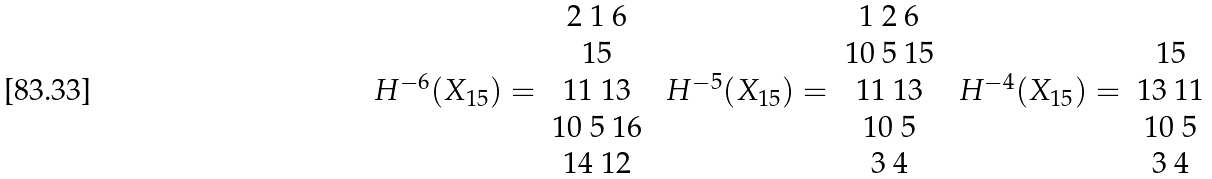<formula> <loc_0><loc_0><loc_500><loc_500>\begin{array} { c c } & 2 \ 1 \ 6 \\ & 1 5 \\ H ^ { - 6 } ( X _ { 1 5 } ) = & 1 1 \ 1 3 \\ & 1 0 \ 5 \ 1 6 \\ & 1 4 \ 1 2 \\ \end{array} \ \begin{array} { c c } & 1 \ 2 \ 6 \\ & 1 0 \ 5 \ 1 5 \\ H ^ { - 5 } ( X _ { 1 5 } ) = & 1 1 \ 1 3 \\ & 1 0 \ 5 \\ & 3 \ 4 \\ \end{array} \ \begin{array} { c c } & \\ & 1 5 \\ H ^ { - 4 } ( X _ { 1 5 } ) = & 1 3 \ 1 1 \\ & 1 0 \ 5 \\ & 3 \ 4 \\ \end{array}</formula> 